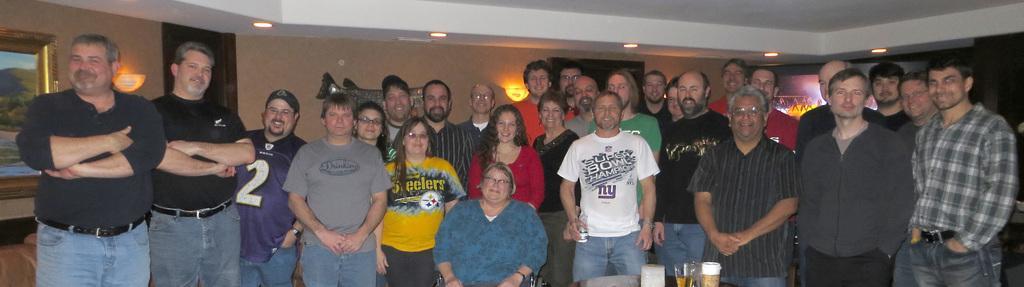Could you give a brief overview of what you see in this image? In this image we can see group of people. There is a table. On the table we can see glasses. In the background we can see wall, ceiling, lights, frame, screen, and objects. 